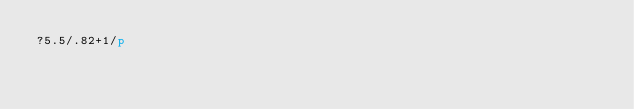Convert code to text. <code><loc_0><loc_0><loc_500><loc_500><_dc_>?5.5/.82+1/p</code> 